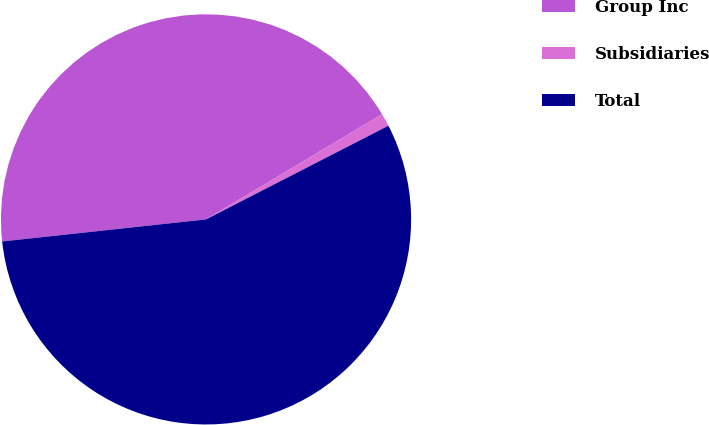Convert chart to OTSL. <chart><loc_0><loc_0><loc_500><loc_500><pie_chart><fcel>Group Inc<fcel>Subsidiaries<fcel>Total<nl><fcel>43.14%<fcel>1.02%<fcel>55.83%<nl></chart> 